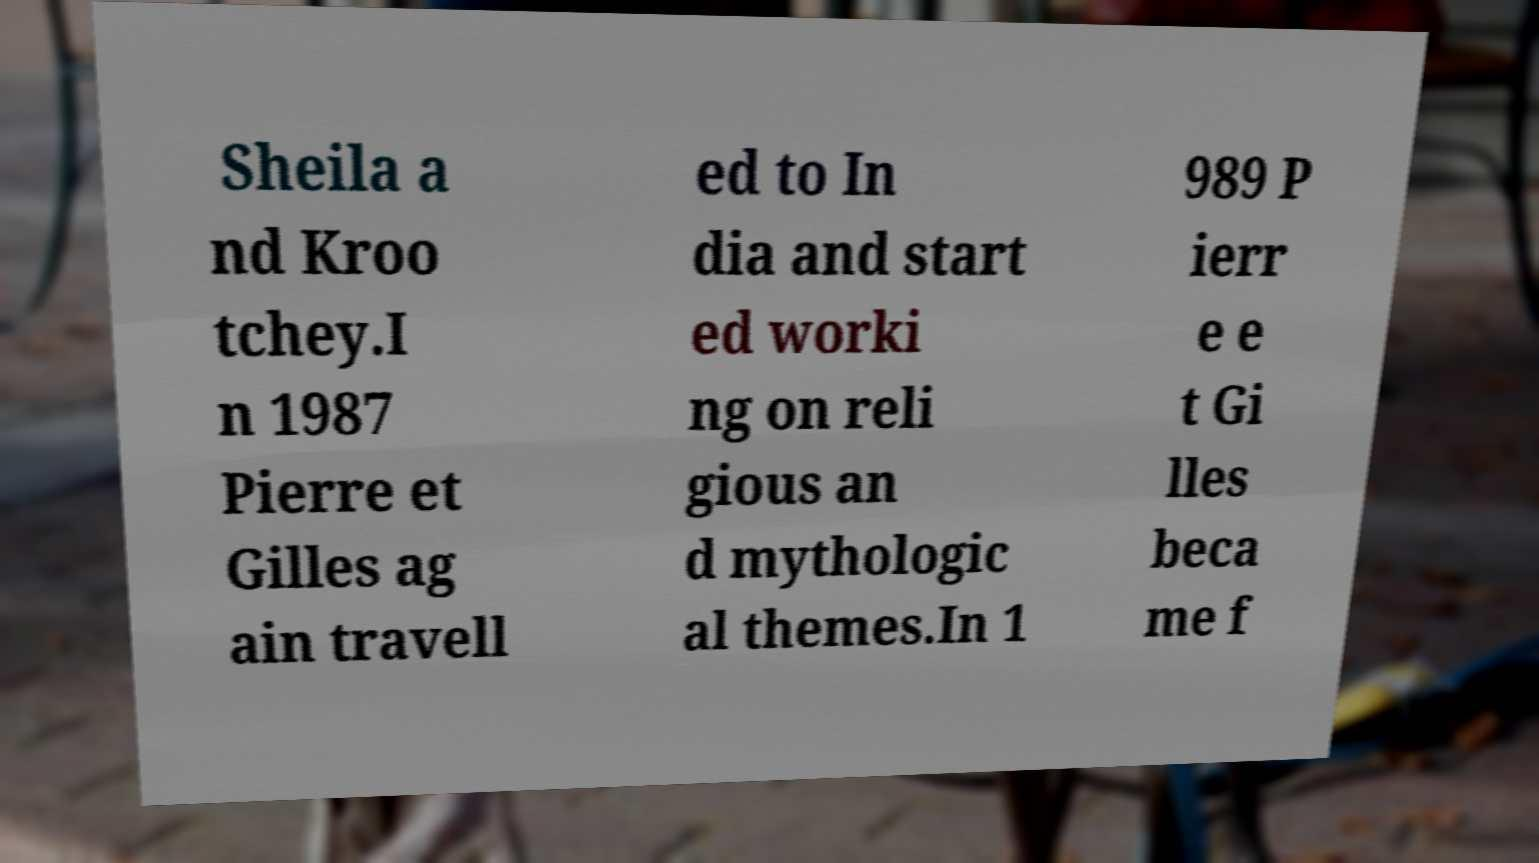Could you extract and type out the text from this image? Sheila a nd Kroo tchey.I n 1987 Pierre et Gilles ag ain travell ed to In dia and start ed worki ng on reli gious an d mythologic al themes.In 1 989 P ierr e e t Gi lles beca me f 